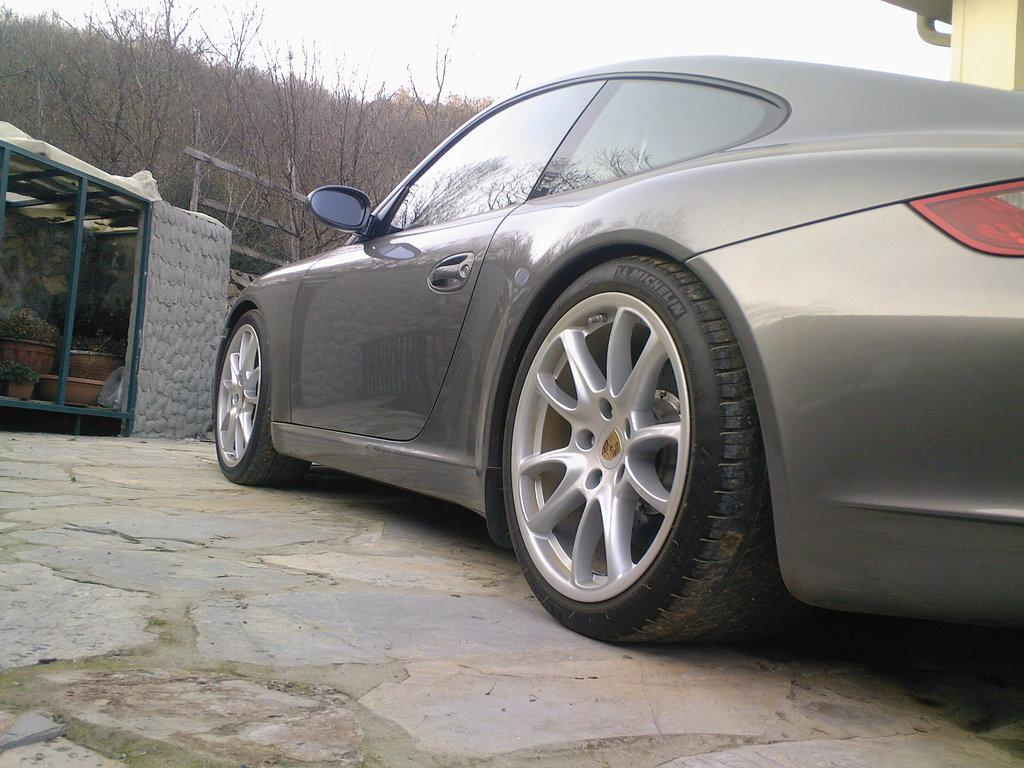What type of motor vehicle is on the floor in the image? The facts do not specify the type of motor vehicle, only that there is one on the floor. What other objects or living things can be seen in the image? There are house plants, a shade, trees, and the sky visible in the image. Can you describe the shade in the image? The facts do not provide specific details about the shade, only that it is present in the image. What type of vegetation is visible in the image? There are house plants and trees visible in the image. How many zebras can be seen swimming in the territory depicted in the image? There are no zebras or territories depicted in the image; it features a motor vehicle on the floor, house plants, a shade, trees, and the sky. Can you describe the jellyfish floating in the water in the image? There is no water or jellyfish present in the image. 